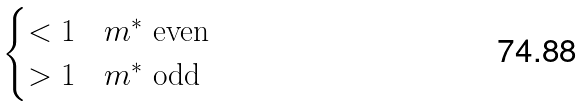Convert formula to latex. <formula><loc_0><loc_0><loc_500><loc_500>\begin{cases} < 1 & m ^ { * } \text { even } \\ > 1 & m ^ { * } \text { odd} \end{cases}</formula> 